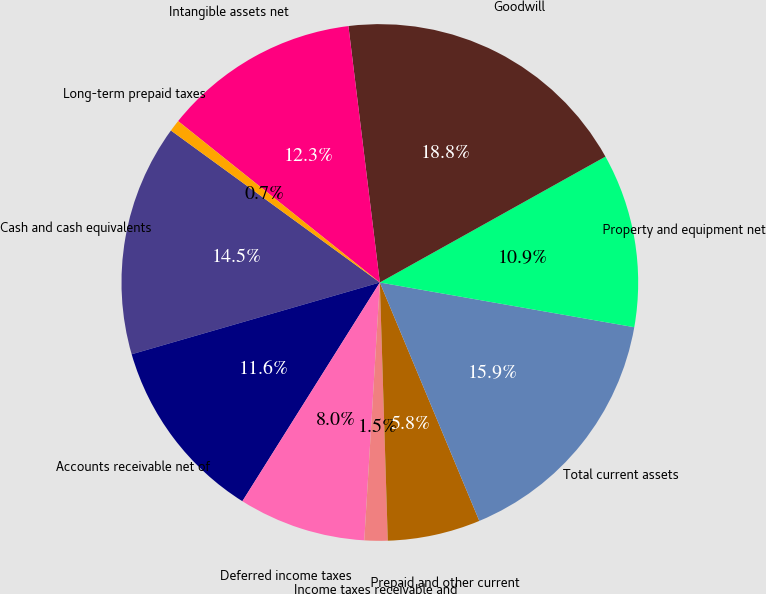Convert chart to OTSL. <chart><loc_0><loc_0><loc_500><loc_500><pie_chart><fcel>Cash and cash equivalents<fcel>Accounts receivable net of<fcel>Deferred income taxes<fcel>Income taxes receivable and<fcel>Prepaid and other current<fcel>Total current assets<fcel>Property and equipment net<fcel>Goodwill<fcel>Intangible assets net<fcel>Long-term prepaid taxes<nl><fcel>14.49%<fcel>11.59%<fcel>7.97%<fcel>1.45%<fcel>5.8%<fcel>15.94%<fcel>10.87%<fcel>18.84%<fcel>12.32%<fcel>0.73%<nl></chart> 